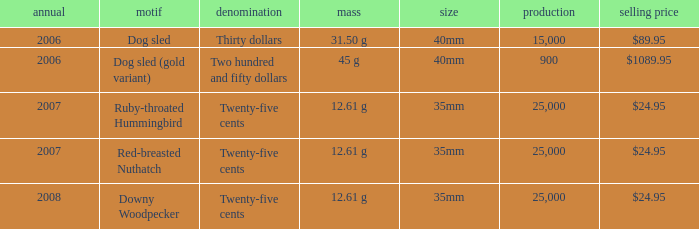What is the Mintage of the 12.61 g Weight Ruby-Throated Hummingbird? 1.0. 